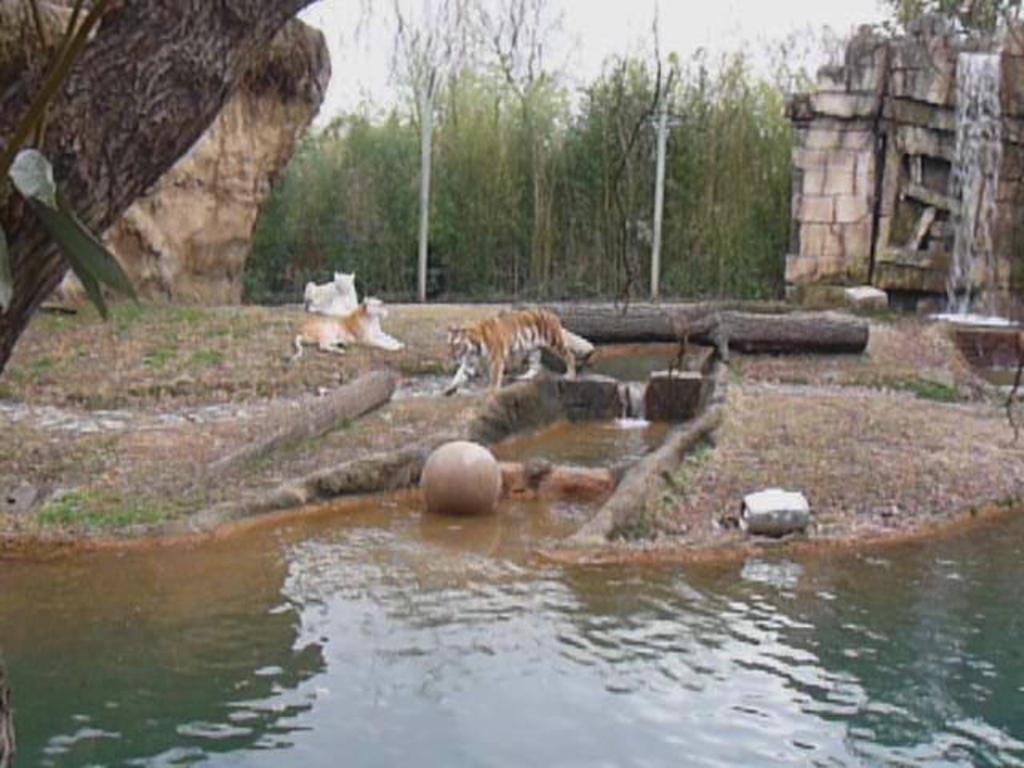What is the primary element present in the image? There is water in the image. What type of animals can be seen in the image? There are tigers in the image. What structures are visible in the image? There are poles in the image. What type of natural objects are present in the image? There are stones in the image. What can be seen in the background of the image? There are trees in the background of the image. Where is the fire hydrant located in the image? There is no fire hydrant present in the image. What type of water flow can be seen in the image? The image does not depict a stream or any specific type of water flow. 